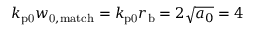<formula> <loc_0><loc_0><loc_500><loc_500>k _ { p 0 } w _ { 0 , m a t c h } = k _ { p 0 } r _ { b } = 2 \sqrt { a _ { 0 } } = 4</formula> 